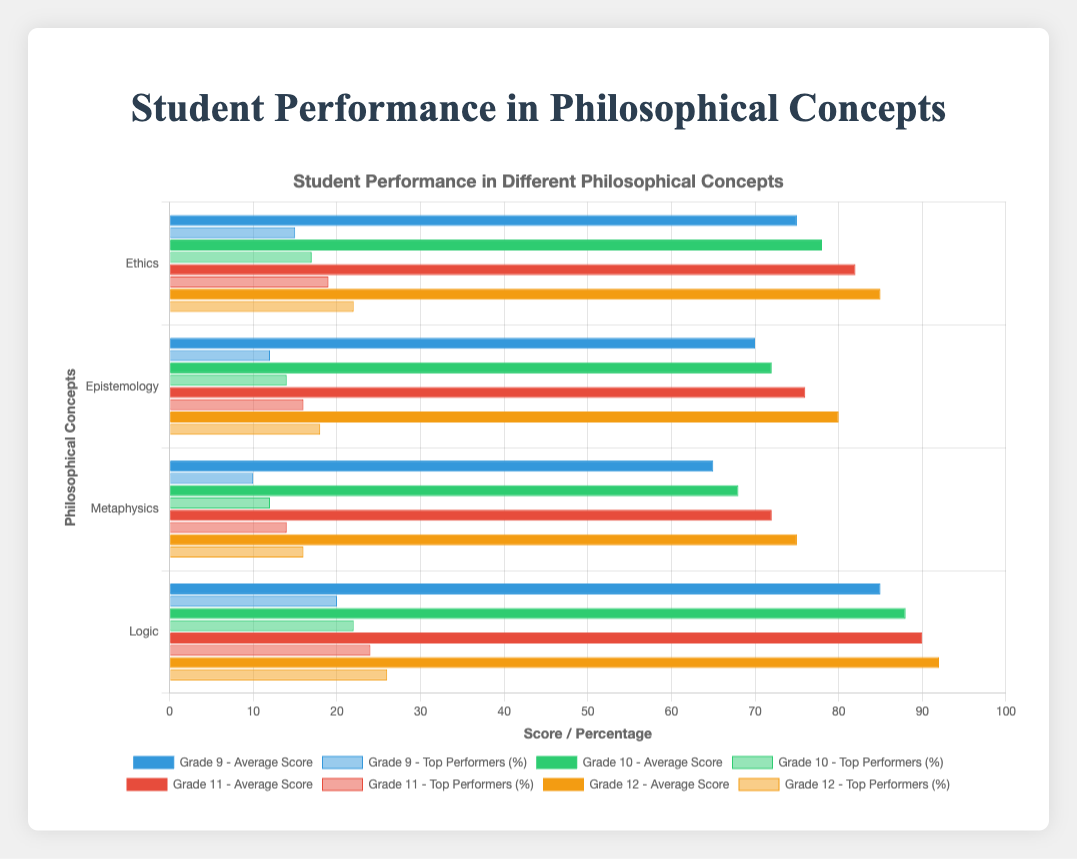Which grade has the highest average score in Logic? Look at the Logic bars for each grade and find the tallest one. Grade 12 has the highest bar.
Answer: Grade 12 How many percentage points higher are the Grade 12 top performers in Epistemology compared to Grade 9? Subtract the Grade 9 top performers percentage for Epistemology from the Grade 12 percentage: 18% - 12% = 6%.
Answer: 6% Which philosophical concept has the lowest average score overall? Compare the shortest bars across all grade levels for each concept. Metaphysics consistently has the lowest bars.
Answer: Metaphysics What is the difference in average scores between Grade 9 and Grade 12 for Ethics? Subtract the Grade 9 average score for Ethics from the Grade 12 average score: 85 - 75 = 10.
Answer: 10 Are there more top performers percentage-wise in Grade 10 or Grade 11 for Logic? Compare the heights of the Logic top performers bars for Grade 10 and Grade 11. Grade 11 has a taller bar.
Answer: Grade 11 Which grade level has the most consistent average scores across all philosophical concepts? Compare the variations in average score heights for each grade across concepts. Grade 12 shows the least variation.
Answer: Grade 12 What is the total average score for Grade 10 across all concepts? Sum the average scores for Grade 10: 78 + 72 + 68 + 88 = 306.
Answer: 306 How much higher is the top performers percentage for Grade 11 in Logic compared to Metaphysics? Subtract the Grade 11 top performers percentage for Metaphysics from Logic: 24% - 14% = 10%.
Answer: 10% Which philosophical concept sees the highest increase in average score from Grade 9 to Grade 12? Calculate the difference in average scores from Grade 9 to Grade 12 for each concept and find the highest: Logic (92-85=7), Epistemology (80-70=10), Metaphysics (75-65=10), Ethics (85-75=10).
Answer: Epistemology, Metaphysics, Ethics (each 10 points) In which philosophical concept are the percentage of top performers in Grade 9 higher than those in Grade 12? Compare the top performers percentages for Grade 9 and Grade 12 in each concept. There is no instance where Grade 9 has a higher percentage than Grade 12.
Answer: None 